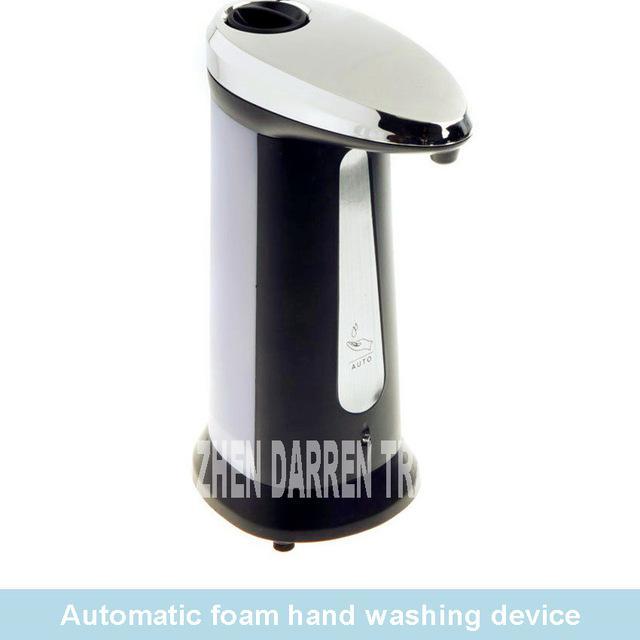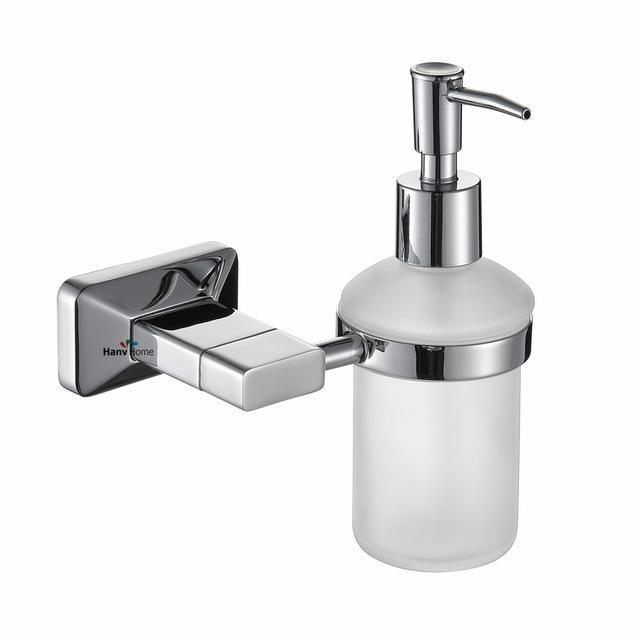The first image is the image on the left, the second image is the image on the right. For the images displayed, is the sentence "There is one dispenser attached to a plastic bottle." factually correct? Answer yes or no. Yes. The first image is the image on the left, the second image is the image on the right. Evaluate the accuracy of this statement regarding the images: "The left and right image contains the same number of sink soap dispensers.". Is it true? Answer yes or no. No. 